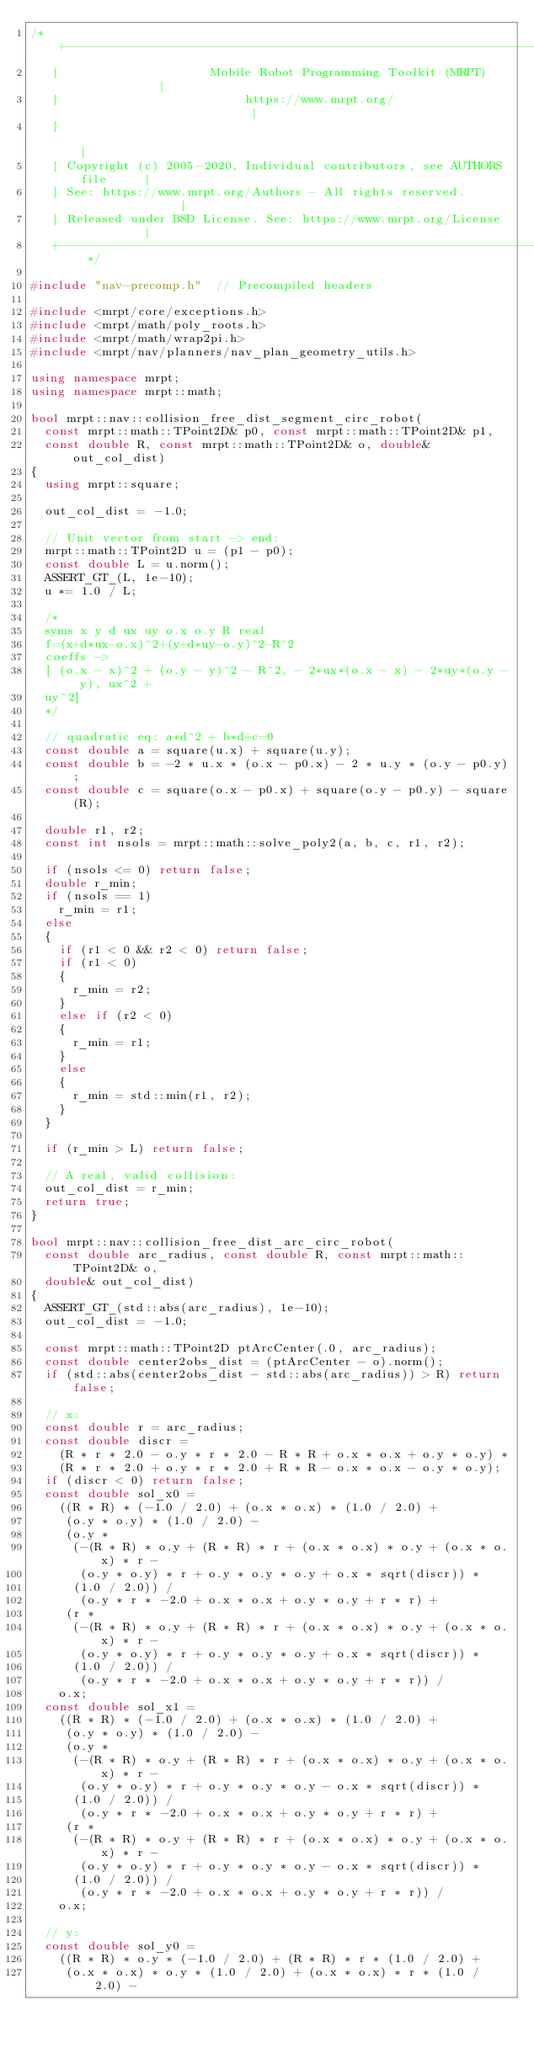Convert code to text. <code><loc_0><loc_0><loc_500><loc_500><_C++_>/* +------------------------------------------------------------------------+
   |                     Mobile Robot Programming Toolkit (MRPT)            |
   |                          https://www.mrpt.org/                         |
   |                                                                        |
   | Copyright (c) 2005-2020, Individual contributors, see AUTHORS file     |
   | See: https://www.mrpt.org/Authors - All rights reserved.               |
   | Released under BSD License. See: https://www.mrpt.org/License          |
   +------------------------------------------------------------------------+ */

#include "nav-precomp.h"  // Precompiled headers

#include <mrpt/core/exceptions.h>
#include <mrpt/math/poly_roots.h>
#include <mrpt/math/wrap2pi.h>
#include <mrpt/nav/planners/nav_plan_geometry_utils.h>

using namespace mrpt;
using namespace mrpt::math;

bool mrpt::nav::collision_free_dist_segment_circ_robot(
	const mrpt::math::TPoint2D& p0, const mrpt::math::TPoint2D& p1,
	const double R, const mrpt::math::TPoint2D& o, double& out_col_dist)
{
	using mrpt::square;

	out_col_dist = -1.0;

	// Unit vector from start -> end:
	mrpt::math::TPoint2D u = (p1 - p0);
	const double L = u.norm();
	ASSERT_GT_(L, 1e-10);
	u *= 1.0 / L;

	/*
	syms x y d ux uy o.x o.y R real
	f=(x+d*ux-o.x)^2+(y+d*uy-o.y)^2-R^2
	coeffs ->
	[ (o.x - x)^2 + (o.y - y)^2 - R^2, - 2*ux*(o.x - x) - 2*uy*(o.y - y), ux^2 +
	uy^2]
	*/

	// quadratic eq: a*d^2 + b*d+c=0
	const double a = square(u.x) + square(u.y);
	const double b = -2 * u.x * (o.x - p0.x) - 2 * u.y * (o.y - p0.y);
	const double c = square(o.x - p0.x) + square(o.y - p0.y) - square(R);

	double r1, r2;
	const int nsols = mrpt::math::solve_poly2(a, b, c, r1, r2);

	if (nsols <= 0) return false;
	double r_min;
	if (nsols == 1)
		r_min = r1;
	else
	{
		if (r1 < 0 && r2 < 0) return false;
		if (r1 < 0)
		{
			r_min = r2;
		}
		else if (r2 < 0)
		{
			r_min = r1;
		}
		else
		{
			r_min = std::min(r1, r2);
		}
	}

	if (r_min > L) return false;

	// A real, valid collision:
	out_col_dist = r_min;
	return true;
}

bool mrpt::nav::collision_free_dist_arc_circ_robot(
	const double arc_radius, const double R, const mrpt::math::TPoint2D& o,
	double& out_col_dist)
{
	ASSERT_GT_(std::abs(arc_radius), 1e-10);
	out_col_dist = -1.0;

	const mrpt::math::TPoint2D ptArcCenter(.0, arc_radius);
	const double center2obs_dist = (ptArcCenter - o).norm();
	if (std::abs(center2obs_dist - std::abs(arc_radius)) > R) return false;

	// x:
	const double r = arc_radius;
	const double discr =
		(R * r * 2.0 - o.y * r * 2.0 - R * R + o.x * o.x + o.y * o.y) *
		(R * r * 2.0 + o.y * r * 2.0 + R * R - o.x * o.x - o.y * o.y);
	if (discr < 0) return false;
	const double sol_x0 =
		((R * R) * (-1.0 / 2.0) + (o.x * o.x) * (1.0 / 2.0) +
		 (o.y * o.y) * (1.0 / 2.0) -
		 (o.y *
		  (-(R * R) * o.y + (R * R) * r + (o.x * o.x) * o.y + (o.x * o.x) * r -
		   (o.y * o.y) * r + o.y * o.y * o.y + o.x * sqrt(discr)) *
		  (1.0 / 2.0)) /
			 (o.y * r * -2.0 + o.x * o.x + o.y * o.y + r * r) +
		 (r *
		  (-(R * R) * o.y + (R * R) * r + (o.x * o.x) * o.y + (o.x * o.x) * r -
		   (o.y * o.y) * r + o.y * o.y * o.y + o.x * sqrt(discr)) *
		  (1.0 / 2.0)) /
			 (o.y * r * -2.0 + o.x * o.x + o.y * o.y + r * r)) /
		o.x;
	const double sol_x1 =
		((R * R) * (-1.0 / 2.0) + (o.x * o.x) * (1.0 / 2.0) +
		 (o.y * o.y) * (1.0 / 2.0) -
		 (o.y *
		  (-(R * R) * o.y + (R * R) * r + (o.x * o.x) * o.y + (o.x * o.x) * r -
		   (o.y * o.y) * r + o.y * o.y * o.y - o.x * sqrt(discr)) *
		  (1.0 / 2.0)) /
			 (o.y * r * -2.0 + o.x * o.x + o.y * o.y + r * r) +
		 (r *
		  (-(R * R) * o.y + (R * R) * r + (o.x * o.x) * o.y + (o.x * o.x) * r -
		   (o.y * o.y) * r + o.y * o.y * o.y - o.x * sqrt(discr)) *
		  (1.0 / 2.0)) /
			 (o.y * r * -2.0 + o.x * o.x + o.y * o.y + r * r)) /
		o.x;

	// y:
	const double sol_y0 =
		((R * R) * o.y * (-1.0 / 2.0) + (R * R) * r * (1.0 / 2.0) +
		 (o.x * o.x) * o.y * (1.0 / 2.0) + (o.x * o.x) * r * (1.0 / 2.0) -</code> 